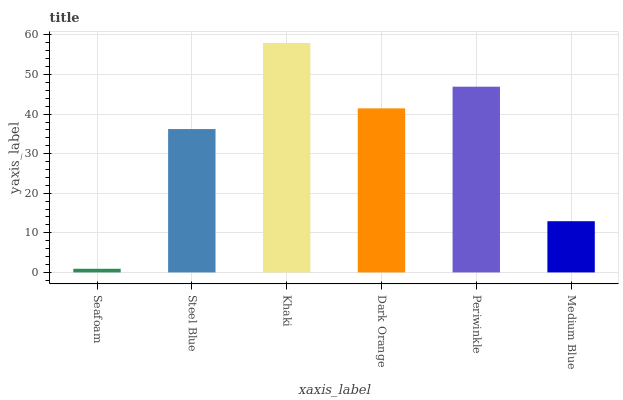Is Seafoam the minimum?
Answer yes or no. Yes. Is Khaki the maximum?
Answer yes or no. Yes. Is Steel Blue the minimum?
Answer yes or no. No. Is Steel Blue the maximum?
Answer yes or no. No. Is Steel Blue greater than Seafoam?
Answer yes or no. Yes. Is Seafoam less than Steel Blue?
Answer yes or no. Yes. Is Seafoam greater than Steel Blue?
Answer yes or no. No. Is Steel Blue less than Seafoam?
Answer yes or no. No. Is Dark Orange the high median?
Answer yes or no. Yes. Is Steel Blue the low median?
Answer yes or no. Yes. Is Periwinkle the high median?
Answer yes or no. No. Is Khaki the low median?
Answer yes or no. No. 